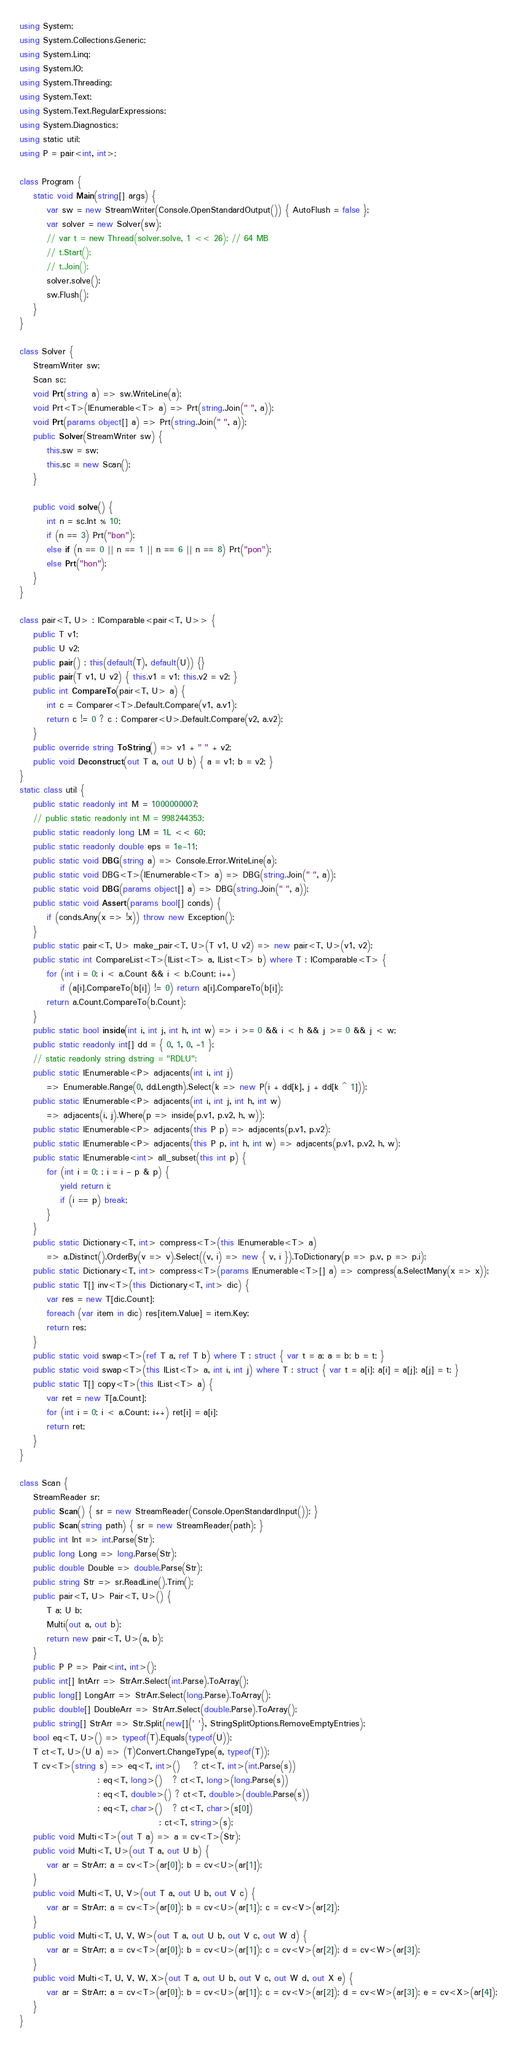Convert code to text. <code><loc_0><loc_0><loc_500><loc_500><_C#_>using System;
using System.Collections.Generic;
using System.Linq;
using System.IO;
using System.Threading;
using System.Text;
using System.Text.RegularExpressions;
using System.Diagnostics;
using static util;
using P = pair<int, int>;

class Program {
    static void Main(string[] args) {
        var sw = new StreamWriter(Console.OpenStandardOutput()) { AutoFlush = false };
        var solver = new Solver(sw);
        // var t = new Thread(solver.solve, 1 << 26); // 64 MB
        // t.Start();
        // t.Join();
        solver.solve();
        sw.Flush();
    }
}

class Solver {
    StreamWriter sw;
    Scan sc;
    void Prt(string a) => sw.WriteLine(a);
    void Prt<T>(IEnumerable<T> a) => Prt(string.Join(" ", a));
    void Prt(params object[] a) => Prt(string.Join(" ", a));
    public Solver(StreamWriter sw) {
        this.sw = sw;
        this.sc = new Scan();
    }

    public void solve() {
        int n = sc.Int % 10;
        if (n == 3) Prt("bon");
        else if (n == 0 || n == 1 || n == 6 || n == 8) Prt("pon");
        else Prt("hon");
    }
}

class pair<T, U> : IComparable<pair<T, U>> {
    public T v1;
    public U v2;
    public pair() : this(default(T), default(U)) {}
    public pair(T v1, U v2) { this.v1 = v1; this.v2 = v2; }
    public int CompareTo(pair<T, U> a) {
        int c = Comparer<T>.Default.Compare(v1, a.v1);
        return c != 0 ? c : Comparer<U>.Default.Compare(v2, a.v2);
    }
    public override string ToString() => v1 + " " + v2;
    public void Deconstruct(out T a, out U b) { a = v1; b = v2; }
}
static class util {
    public static readonly int M = 1000000007;
    // public static readonly int M = 998244353;
    public static readonly long LM = 1L << 60;
    public static readonly double eps = 1e-11;
    public static void DBG(string a) => Console.Error.WriteLine(a);
    public static void DBG<T>(IEnumerable<T> a) => DBG(string.Join(" ", a));
    public static void DBG(params object[] a) => DBG(string.Join(" ", a));
    public static void Assert(params bool[] conds) {
        if (conds.Any(x => !x)) throw new Exception();
    }
    public static pair<T, U> make_pair<T, U>(T v1, U v2) => new pair<T, U>(v1, v2);
    public static int CompareList<T>(IList<T> a, IList<T> b) where T : IComparable<T> {
        for (int i = 0; i < a.Count && i < b.Count; i++)
            if (a[i].CompareTo(b[i]) != 0) return a[i].CompareTo(b[i]);
        return a.Count.CompareTo(b.Count);
    }
    public static bool inside(int i, int j, int h, int w) => i >= 0 && i < h && j >= 0 && j < w;
    public static readonly int[] dd = { 0, 1, 0, -1 };
    // static readonly string dstring = "RDLU";
    public static IEnumerable<P> adjacents(int i, int j)
        => Enumerable.Range(0, dd.Length).Select(k => new P(i + dd[k], j + dd[k ^ 1]));
    public static IEnumerable<P> adjacents(int i, int j, int h, int w)
        => adjacents(i, j).Where(p => inside(p.v1, p.v2, h, w));
    public static IEnumerable<P> adjacents(this P p) => adjacents(p.v1, p.v2);
    public static IEnumerable<P> adjacents(this P p, int h, int w) => adjacents(p.v1, p.v2, h, w);
    public static IEnumerable<int> all_subset(this int p) {
        for (int i = 0; ; i = i - p & p) {
            yield return i;
            if (i == p) break;
        }
    }
    public static Dictionary<T, int> compress<T>(this IEnumerable<T> a)
        => a.Distinct().OrderBy(v => v).Select((v, i) => new { v, i }).ToDictionary(p => p.v, p => p.i);
    public static Dictionary<T, int> compress<T>(params IEnumerable<T>[] a) => compress(a.SelectMany(x => x));
    public static T[] inv<T>(this Dictionary<T, int> dic) {
        var res = new T[dic.Count];
        foreach (var item in dic) res[item.Value] = item.Key;
        return res;
    }
    public static void swap<T>(ref T a, ref T b) where T : struct { var t = a; a = b; b = t; }
    public static void swap<T>(this IList<T> a, int i, int j) where T : struct { var t = a[i]; a[i] = a[j]; a[j] = t; }
    public static T[] copy<T>(this IList<T> a) {
        var ret = new T[a.Count];
        for (int i = 0; i < a.Count; i++) ret[i] = a[i];
        return ret;
    }
}

class Scan {
    StreamReader sr;
    public Scan() { sr = new StreamReader(Console.OpenStandardInput()); }
    public Scan(string path) { sr = new StreamReader(path); }
    public int Int => int.Parse(Str);
    public long Long => long.Parse(Str);
    public double Double => double.Parse(Str);
    public string Str => sr.ReadLine().Trim();
    public pair<T, U> Pair<T, U>() {
        T a; U b;
        Multi(out a, out b);
        return new pair<T, U>(a, b);
    }
    public P P => Pair<int, int>();
    public int[] IntArr => StrArr.Select(int.Parse).ToArray();
    public long[] LongArr => StrArr.Select(long.Parse).ToArray();
    public double[] DoubleArr => StrArr.Select(double.Parse).ToArray();
    public string[] StrArr => Str.Split(new[]{' '}, StringSplitOptions.RemoveEmptyEntries);
    bool eq<T, U>() => typeof(T).Equals(typeof(U));
    T ct<T, U>(U a) => (T)Convert.ChangeType(a, typeof(T));
    T cv<T>(string s) => eq<T, int>()    ? ct<T, int>(int.Parse(s))
                       : eq<T, long>()   ? ct<T, long>(long.Parse(s))
                       : eq<T, double>() ? ct<T, double>(double.Parse(s))
                       : eq<T, char>()   ? ct<T, char>(s[0])
                                         : ct<T, string>(s);
    public void Multi<T>(out T a) => a = cv<T>(Str);
    public void Multi<T, U>(out T a, out U b) {
        var ar = StrArr; a = cv<T>(ar[0]); b = cv<U>(ar[1]);
    }
    public void Multi<T, U, V>(out T a, out U b, out V c) {
        var ar = StrArr; a = cv<T>(ar[0]); b = cv<U>(ar[1]); c = cv<V>(ar[2]);
    }
    public void Multi<T, U, V, W>(out T a, out U b, out V c, out W d) {
        var ar = StrArr; a = cv<T>(ar[0]); b = cv<U>(ar[1]); c = cv<V>(ar[2]); d = cv<W>(ar[3]);
    }
    public void Multi<T, U, V, W, X>(out T a, out U b, out V c, out W d, out X e) {
        var ar = StrArr; a = cv<T>(ar[0]); b = cv<U>(ar[1]); c = cv<V>(ar[2]); d = cv<W>(ar[3]); e = cv<X>(ar[4]);
    }
}
</code> 